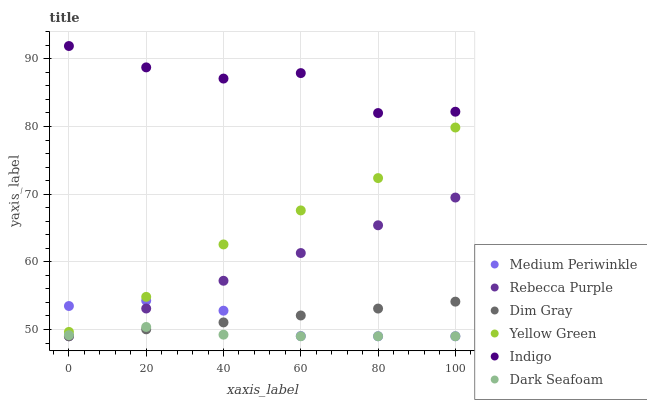Does Dark Seafoam have the minimum area under the curve?
Answer yes or no. Yes. Does Indigo have the maximum area under the curve?
Answer yes or no. Yes. Does Yellow Green have the minimum area under the curve?
Answer yes or no. No. Does Yellow Green have the maximum area under the curve?
Answer yes or no. No. Is Dim Gray the smoothest?
Answer yes or no. Yes. Is Indigo the roughest?
Answer yes or no. Yes. Is Yellow Green the smoothest?
Answer yes or no. No. Is Yellow Green the roughest?
Answer yes or no. No. Does Dim Gray have the lowest value?
Answer yes or no. Yes. Does Yellow Green have the lowest value?
Answer yes or no. No. Does Indigo have the highest value?
Answer yes or no. Yes. Does Yellow Green have the highest value?
Answer yes or no. No. Is Yellow Green less than Indigo?
Answer yes or no. Yes. Is Indigo greater than Dim Gray?
Answer yes or no. Yes. Does Yellow Green intersect Medium Periwinkle?
Answer yes or no. Yes. Is Yellow Green less than Medium Periwinkle?
Answer yes or no. No. Is Yellow Green greater than Medium Periwinkle?
Answer yes or no. No. Does Yellow Green intersect Indigo?
Answer yes or no. No. 